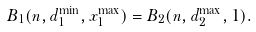<formula> <loc_0><loc_0><loc_500><loc_500>B _ { 1 } ( n , d _ { 1 } ^ { \min } , x _ { 1 } ^ { \max } ) = B _ { 2 } ( n , d _ { 2 } ^ { \max } , 1 ) .</formula> 